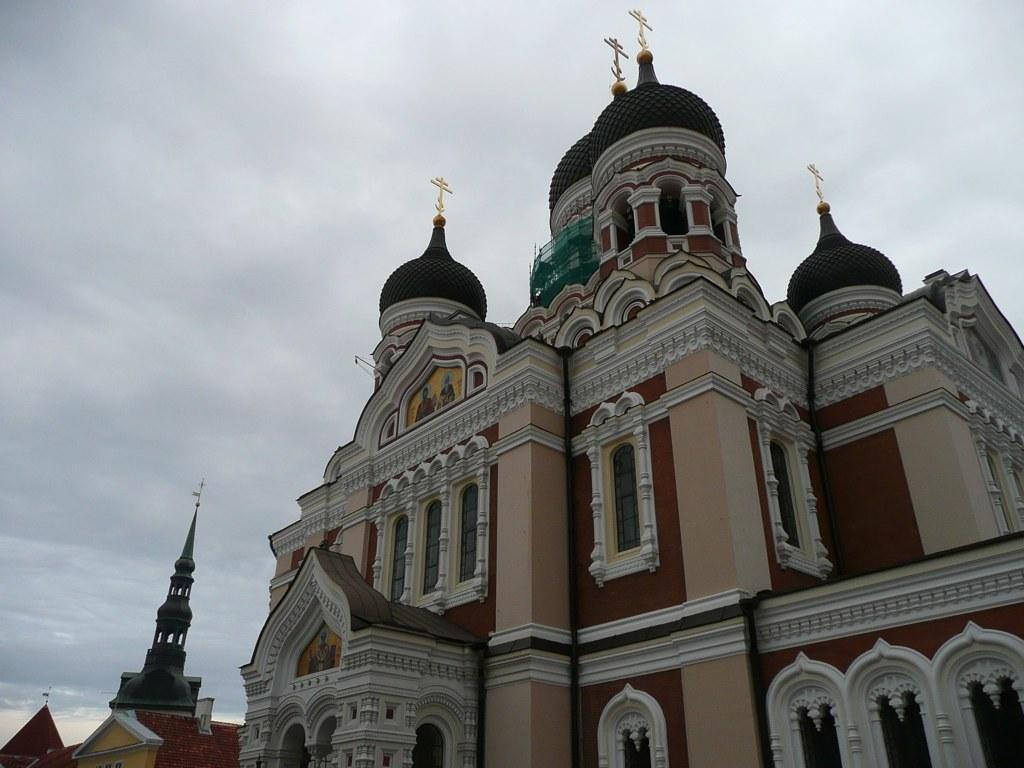What is the main subject in the center of the image? There is a building in the center of the image. Is there a horse standing in the quicksand near the building in the image? There is no horse or quicksand present in the image; it only features a building. 